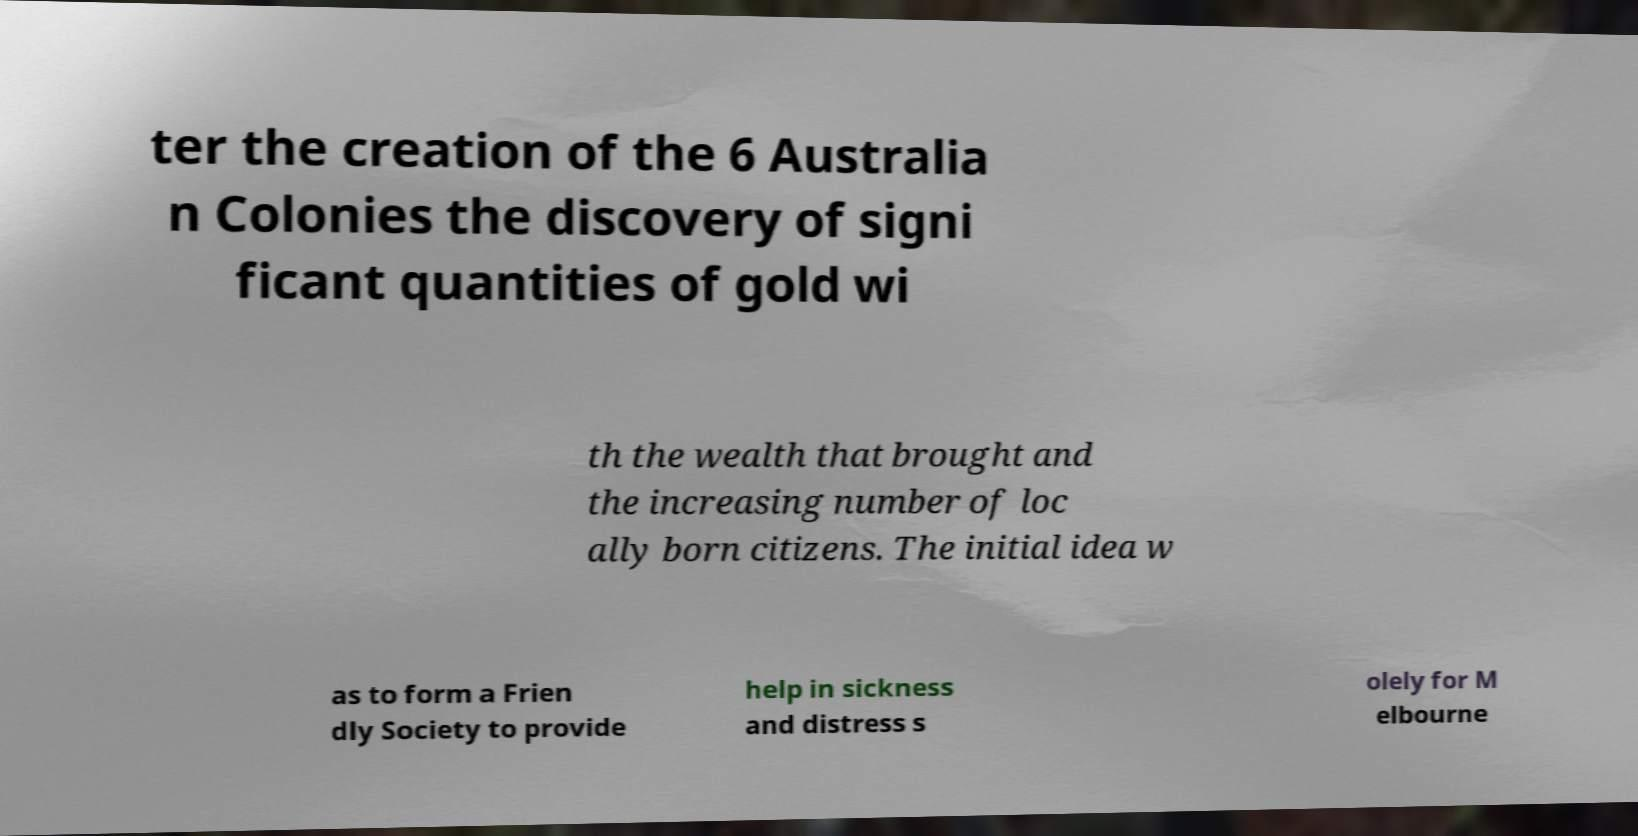Could you extract and type out the text from this image? ter the creation of the 6 Australia n Colonies the discovery of signi ficant quantities of gold wi th the wealth that brought and the increasing number of loc ally born citizens. The initial idea w as to form a Frien dly Society to provide help in sickness and distress s olely for M elbourne 